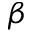<formula> <loc_0><loc_0><loc_500><loc_500>\beta</formula> 